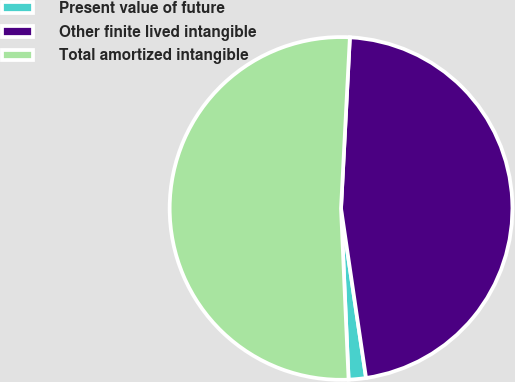Convert chart. <chart><loc_0><loc_0><loc_500><loc_500><pie_chart><fcel>Present value of future<fcel>Other finite lived intangible<fcel>Total amortized intangible<nl><fcel>1.63%<fcel>46.84%<fcel>51.52%<nl></chart> 